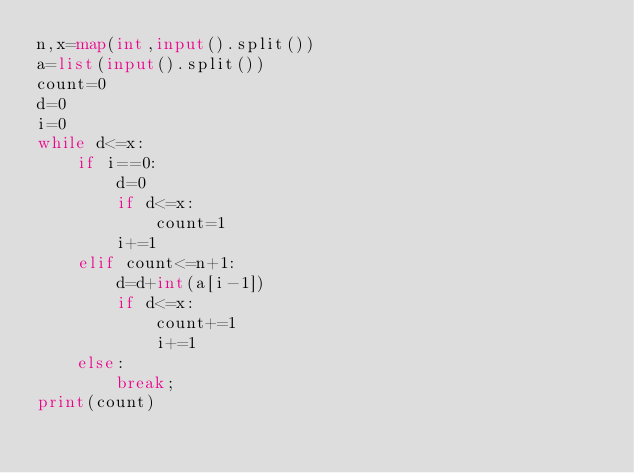Convert code to text. <code><loc_0><loc_0><loc_500><loc_500><_Python_>n,x=map(int,input().split())
a=list(input().split())
count=0
d=0
i=0
while d<=x:
    if i==0:
        d=0
        if d<=x:
            count=1
        i+=1
    elif count<=n+1:
        d=d+int(a[i-1])
        if d<=x:
            count+=1
            i+=1
    else:
        break;
print(count)</code> 